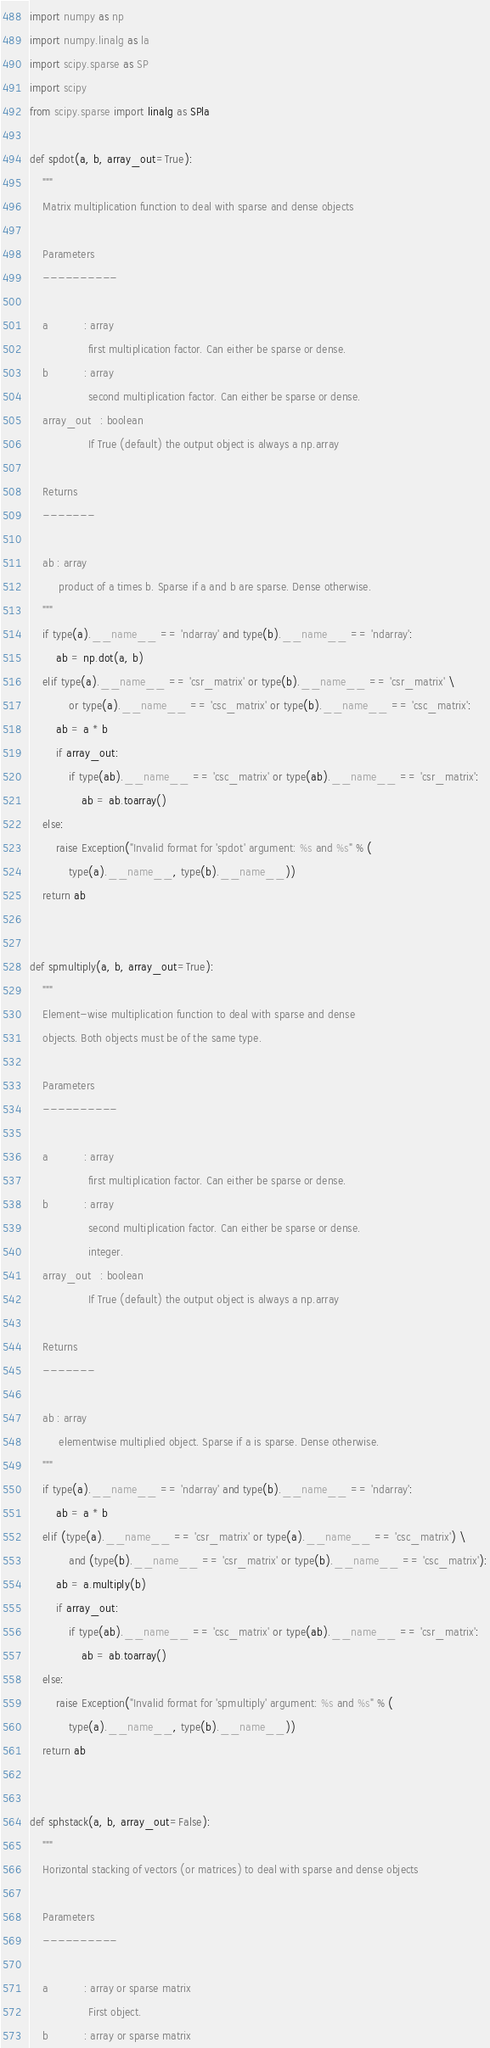<code> <loc_0><loc_0><loc_500><loc_500><_Python_>import numpy as np
import numpy.linalg as la
import scipy.sparse as SP
import scipy
from scipy.sparse import linalg as SPla

def spdot(a, b, array_out=True):
    """
    Matrix multiplication function to deal with sparse and dense objects

    Parameters
    ----------

    a           : array
                  first multiplication factor. Can either be sparse or dense.
    b           : array
                  second multiplication factor. Can either be sparse or dense.
    array_out   : boolean
                  If True (default) the output object is always a np.array

    Returns
    -------

    ab : array
         product of a times b. Sparse if a and b are sparse. Dense otherwise.
    """
    if type(a).__name__ == 'ndarray' and type(b).__name__ == 'ndarray':
        ab = np.dot(a, b)
    elif type(a).__name__ == 'csr_matrix' or type(b).__name__ == 'csr_matrix' \
            or type(a).__name__ == 'csc_matrix' or type(b).__name__ == 'csc_matrix':
        ab = a * b
        if array_out:
            if type(ab).__name__ == 'csc_matrix' or type(ab).__name__ == 'csr_matrix':
                ab = ab.toarray()
    else:
        raise Exception("Invalid format for 'spdot' argument: %s and %s" % (
            type(a).__name__, type(b).__name__))
    return ab


def spmultiply(a, b, array_out=True):
    """
    Element-wise multiplication function to deal with sparse and dense
    objects. Both objects must be of the same type.

    Parameters
    ----------

    a           : array
                  first multiplication factor. Can either be sparse or dense.
    b           : array
                  second multiplication factor. Can either be sparse or dense.
                  integer.
    array_out   : boolean
                  If True (default) the output object is always a np.array

    Returns
    -------

    ab : array
         elementwise multiplied object. Sparse if a is sparse. Dense otherwise.
    """
    if type(a).__name__ == 'ndarray' and type(b).__name__ == 'ndarray':
        ab = a * b
    elif (type(a).__name__ == 'csr_matrix' or type(a).__name__ == 'csc_matrix') \
            and (type(b).__name__ == 'csr_matrix' or type(b).__name__ == 'csc_matrix'):
        ab = a.multiply(b)
        if array_out:
            if type(ab).__name__ == 'csc_matrix' or type(ab).__name__ == 'csr_matrix':
                ab = ab.toarray()
    else:
        raise Exception("Invalid format for 'spmultiply' argument: %s and %s" % (
            type(a).__name__, type(b).__name__))
    return ab


def sphstack(a, b, array_out=False):
    """
    Horizontal stacking of vectors (or matrices) to deal with sparse and dense objects

    Parameters
    ----------

    a           : array or sparse matrix
                  First object.
    b           : array or sparse matrix</code> 